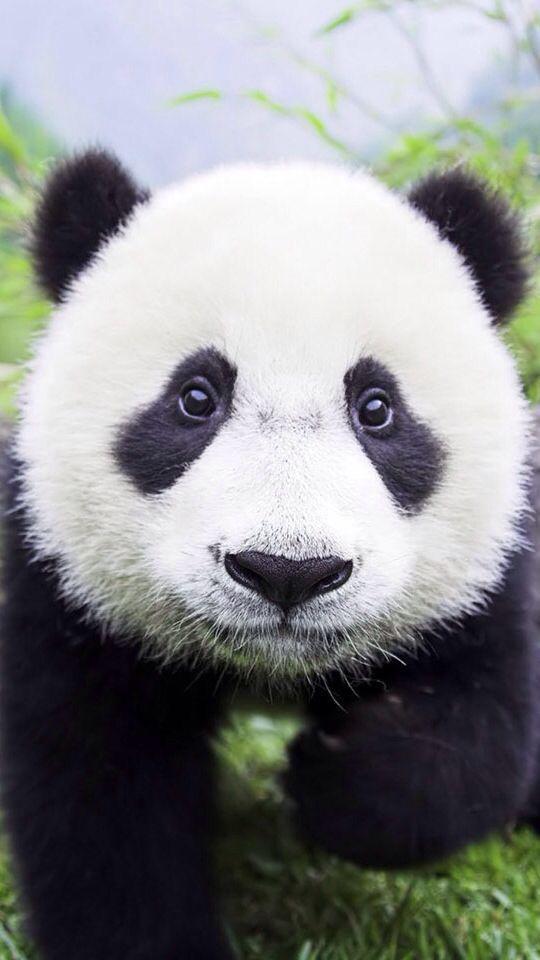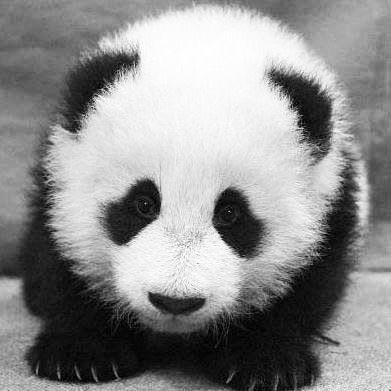The first image is the image on the left, the second image is the image on the right. Given the left and right images, does the statement "One image shows two panda faces, with two sets of eyes visible." hold true? Answer yes or no. No. 